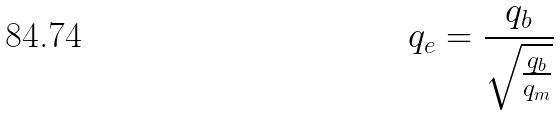Convert formula to latex. <formula><loc_0><loc_0><loc_500><loc_500>q _ { e } = \frac { q _ { b } } { \sqrt { \frac { q _ { b } } { q _ { m } } } }</formula> 